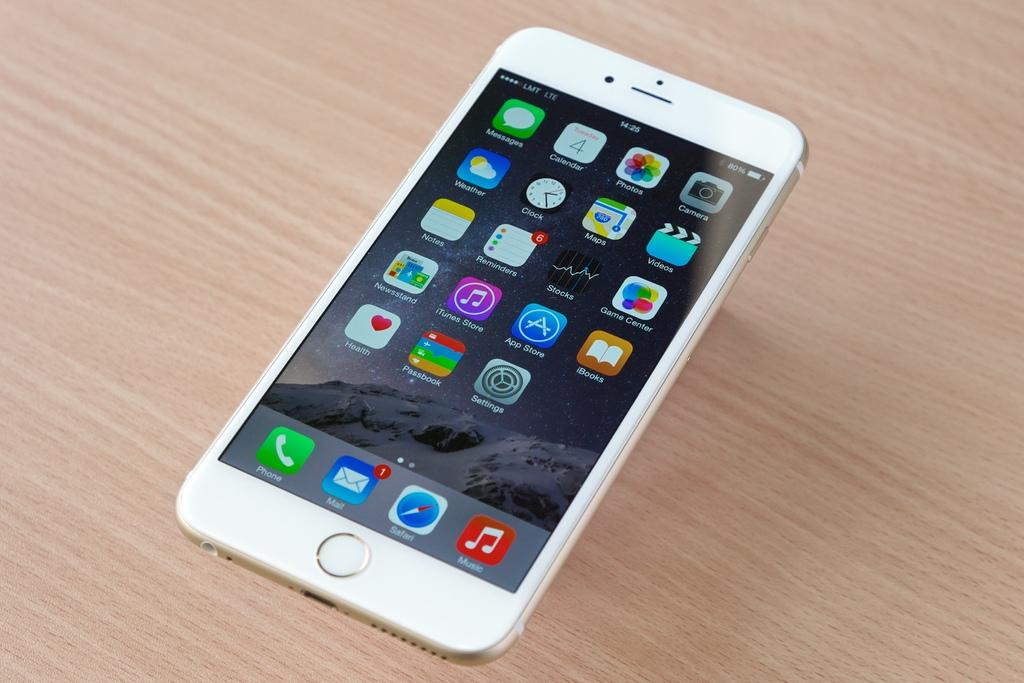What is the quantity of unread mail messages?
Your answer should be compact. 1. What time does the phone show?
Give a very brief answer. 14:25. 